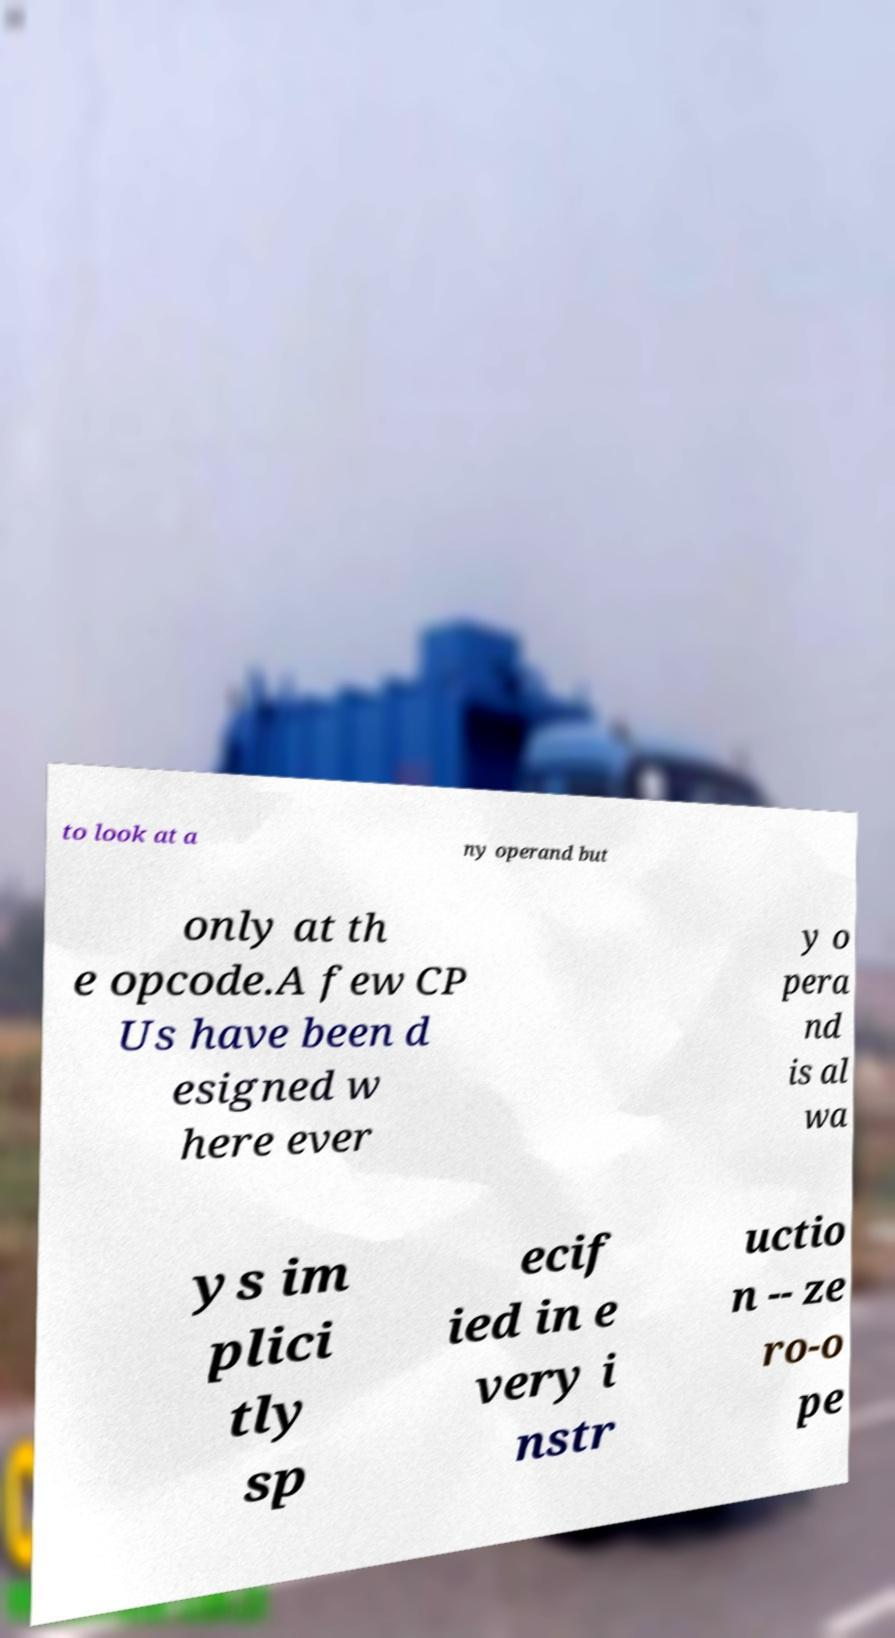Could you extract and type out the text from this image? to look at a ny operand but only at th e opcode.A few CP Us have been d esigned w here ever y o pera nd is al wa ys im plici tly sp ecif ied in e very i nstr uctio n -- ze ro-o pe 